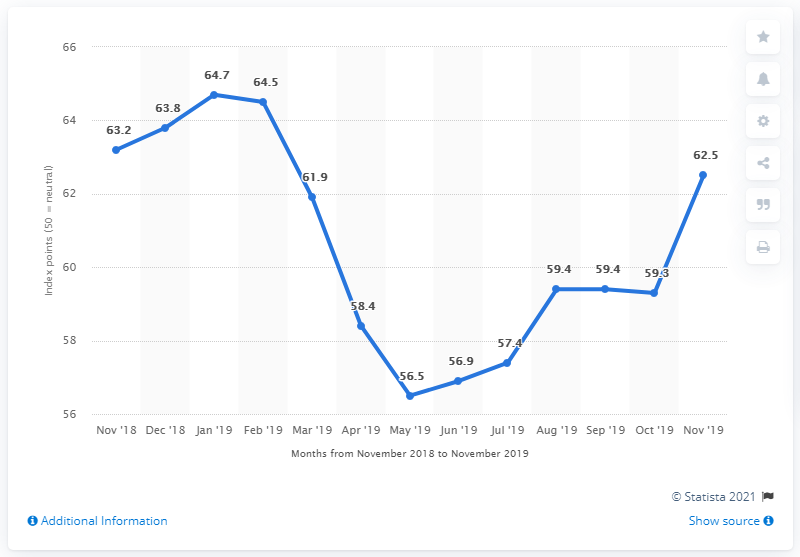List a handful of essential elements in this visual. Brazil's climate index experienced a significant dip in May 2019, with this month being the month that saw the maximum dip in the climate index. The highest climate index is 8.2. 